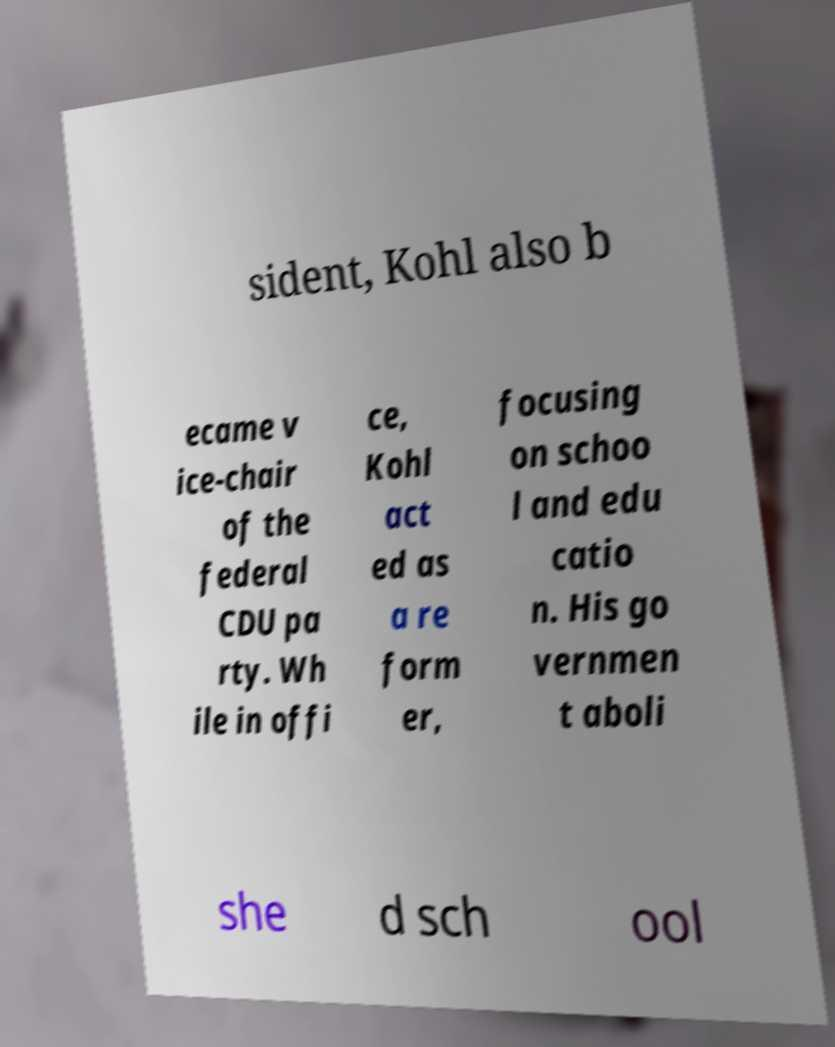There's text embedded in this image that I need extracted. Can you transcribe it verbatim? sident, Kohl also b ecame v ice-chair of the federal CDU pa rty. Wh ile in offi ce, Kohl act ed as a re form er, focusing on schoo l and edu catio n. His go vernmen t aboli she d sch ool 